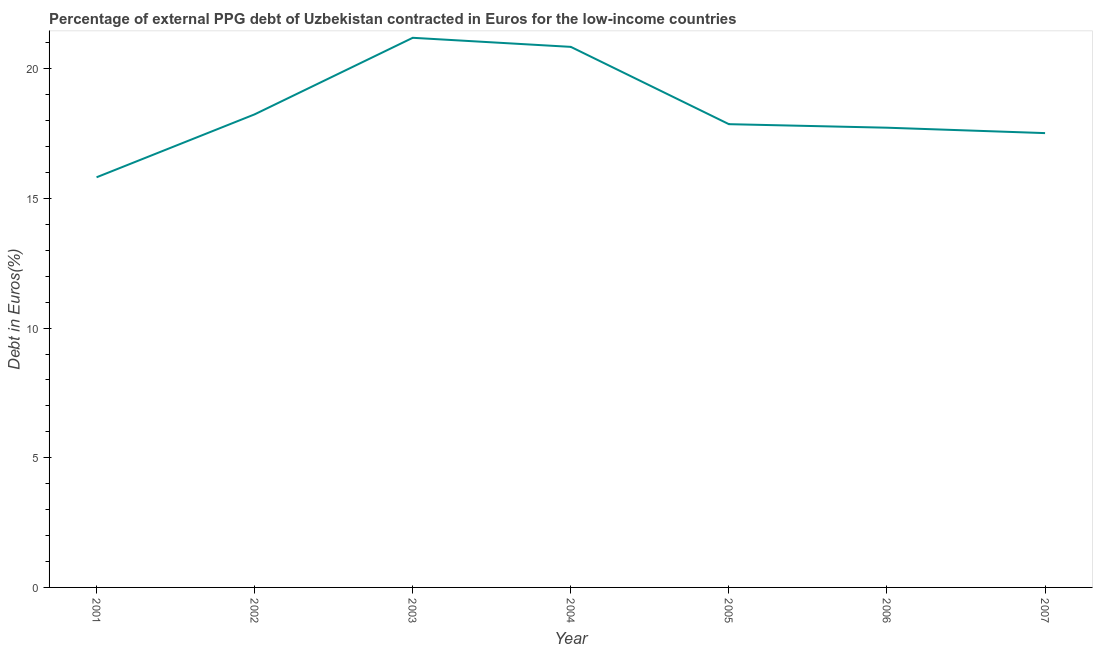What is the currency composition of ppg debt in 2006?
Keep it short and to the point. 17.73. Across all years, what is the maximum currency composition of ppg debt?
Your response must be concise. 21.19. Across all years, what is the minimum currency composition of ppg debt?
Ensure brevity in your answer.  15.81. In which year was the currency composition of ppg debt maximum?
Give a very brief answer. 2003. What is the sum of the currency composition of ppg debt?
Your response must be concise. 129.2. What is the difference between the currency composition of ppg debt in 2003 and 2007?
Provide a short and direct response. 3.67. What is the average currency composition of ppg debt per year?
Offer a terse response. 18.46. What is the median currency composition of ppg debt?
Your answer should be very brief. 17.86. In how many years, is the currency composition of ppg debt greater than 18 %?
Give a very brief answer. 3. What is the ratio of the currency composition of ppg debt in 2006 to that in 2007?
Offer a terse response. 1.01. Is the currency composition of ppg debt in 2004 less than that in 2006?
Make the answer very short. No. What is the difference between the highest and the second highest currency composition of ppg debt?
Offer a very short reply. 0.35. Is the sum of the currency composition of ppg debt in 2002 and 2005 greater than the maximum currency composition of ppg debt across all years?
Your answer should be compact. Yes. What is the difference between the highest and the lowest currency composition of ppg debt?
Offer a very short reply. 5.38. Does the currency composition of ppg debt monotonically increase over the years?
Give a very brief answer. No. How many lines are there?
Make the answer very short. 1. How many years are there in the graph?
Ensure brevity in your answer.  7. Are the values on the major ticks of Y-axis written in scientific E-notation?
Your answer should be very brief. No. Does the graph contain any zero values?
Give a very brief answer. No. What is the title of the graph?
Make the answer very short. Percentage of external PPG debt of Uzbekistan contracted in Euros for the low-income countries. What is the label or title of the X-axis?
Provide a succinct answer. Year. What is the label or title of the Y-axis?
Offer a very short reply. Debt in Euros(%). What is the Debt in Euros(%) in 2001?
Offer a terse response. 15.81. What is the Debt in Euros(%) in 2002?
Give a very brief answer. 18.24. What is the Debt in Euros(%) in 2003?
Make the answer very short. 21.19. What is the Debt in Euros(%) in 2004?
Make the answer very short. 20.84. What is the Debt in Euros(%) in 2005?
Your response must be concise. 17.86. What is the Debt in Euros(%) in 2006?
Ensure brevity in your answer.  17.73. What is the Debt in Euros(%) of 2007?
Make the answer very short. 17.52. What is the difference between the Debt in Euros(%) in 2001 and 2002?
Keep it short and to the point. -2.43. What is the difference between the Debt in Euros(%) in 2001 and 2003?
Make the answer very short. -5.38. What is the difference between the Debt in Euros(%) in 2001 and 2004?
Ensure brevity in your answer.  -5.03. What is the difference between the Debt in Euros(%) in 2001 and 2005?
Ensure brevity in your answer.  -2.05. What is the difference between the Debt in Euros(%) in 2001 and 2006?
Offer a terse response. -1.91. What is the difference between the Debt in Euros(%) in 2001 and 2007?
Give a very brief answer. -1.7. What is the difference between the Debt in Euros(%) in 2002 and 2003?
Offer a terse response. -2.95. What is the difference between the Debt in Euros(%) in 2002 and 2004?
Your response must be concise. -2.6. What is the difference between the Debt in Euros(%) in 2002 and 2005?
Your answer should be compact. 0.38. What is the difference between the Debt in Euros(%) in 2002 and 2006?
Your response must be concise. 0.52. What is the difference between the Debt in Euros(%) in 2002 and 2007?
Your answer should be very brief. 0.72. What is the difference between the Debt in Euros(%) in 2003 and 2004?
Offer a terse response. 0.35. What is the difference between the Debt in Euros(%) in 2003 and 2005?
Keep it short and to the point. 3.33. What is the difference between the Debt in Euros(%) in 2003 and 2006?
Give a very brief answer. 3.47. What is the difference between the Debt in Euros(%) in 2003 and 2007?
Keep it short and to the point. 3.67. What is the difference between the Debt in Euros(%) in 2004 and 2005?
Keep it short and to the point. 2.98. What is the difference between the Debt in Euros(%) in 2004 and 2006?
Make the answer very short. 3.12. What is the difference between the Debt in Euros(%) in 2004 and 2007?
Your response must be concise. 3.33. What is the difference between the Debt in Euros(%) in 2005 and 2006?
Provide a short and direct response. 0.14. What is the difference between the Debt in Euros(%) in 2005 and 2007?
Offer a terse response. 0.34. What is the difference between the Debt in Euros(%) in 2006 and 2007?
Your response must be concise. 0.21. What is the ratio of the Debt in Euros(%) in 2001 to that in 2002?
Offer a terse response. 0.87. What is the ratio of the Debt in Euros(%) in 2001 to that in 2003?
Your response must be concise. 0.75. What is the ratio of the Debt in Euros(%) in 2001 to that in 2004?
Your answer should be very brief. 0.76. What is the ratio of the Debt in Euros(%) in 2001 to that in 2005?
Make the answer very short. 0.89. What is the ratio of the Debt in Euros(%) in 2001 to that in 2006?
Ensure brevity in your answer.  0.89. What is the ratio of the Debt in Euros(%) in 2001 to that in 2007?
Keep it short and to the point. 0.9. What is the ratio of the Debt in Euros(%) in 2002 to that in 2003?
Ensure brevity in your answer.  0.86. What is the ratio of the Debt in Euros(%) in 2002 to that in 2007?
Provide a short and direct response. 1.04. What is the ratio of the Debt in Euros(%) in 2003 to that in 2004?
Ensure brevity in your answer.  1.02. What is the ratio of the Debt in Euros(%) in 2003 to that in 2005?
Make the answer very short. 1.19. What is the ratio of the Debt in Euros(%) in 2003 to that in 2006?
Provide a succinct answer. 1.2. What is the ratio of the Debt in Euros(%) in 2003 to that in 2007?
Give a very brief answer. 1.21. What is the ratio of the Debt in Euros(%) in 2004 to that in 2005?
Provide a succinct answer. 1.17. What is the ratio of the Debt in Euros(%) in 2004 to that in 2006?
Your answer should be very brief. 1.18. What is the ratio of the Debt in Euros(%) in 2004 to that in 2007?
Offer a very short reply. 1.19. 